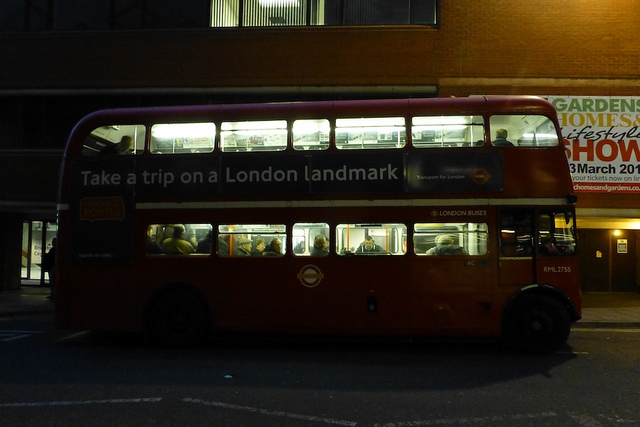What time of day does it appear to be in the image? Given the bus lights are on and it appears to be dark outside, it is likely to be evening or nighttime in the image. Why might people choose to take this bus at night? People might choose to take this bus at night for a variety of reasons including commuting home from work, traveling to social events, or simply enjoying a sightseeing trip around London's landmarks in the evening atmosphere. 